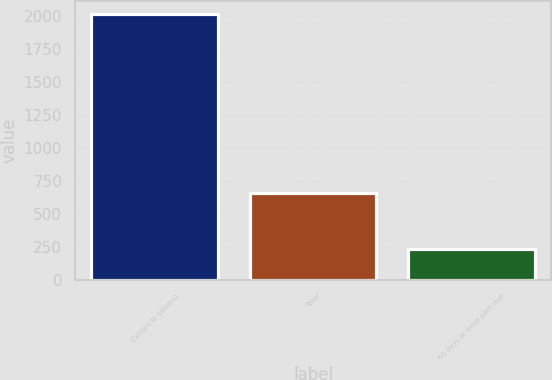<chart> <loc_0><loc_0><loc_500><loc_500><bar_chart><fcel>(Dollars in billions)<fcel>Total<fcel>60 days or more past due<nl><fcel>2011<fcel>659<fcel>235<nl></chart> 